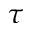Convert formula to latex. <formula><loc_0><loc_0><loc_500><loc_500>\tau</formula> 